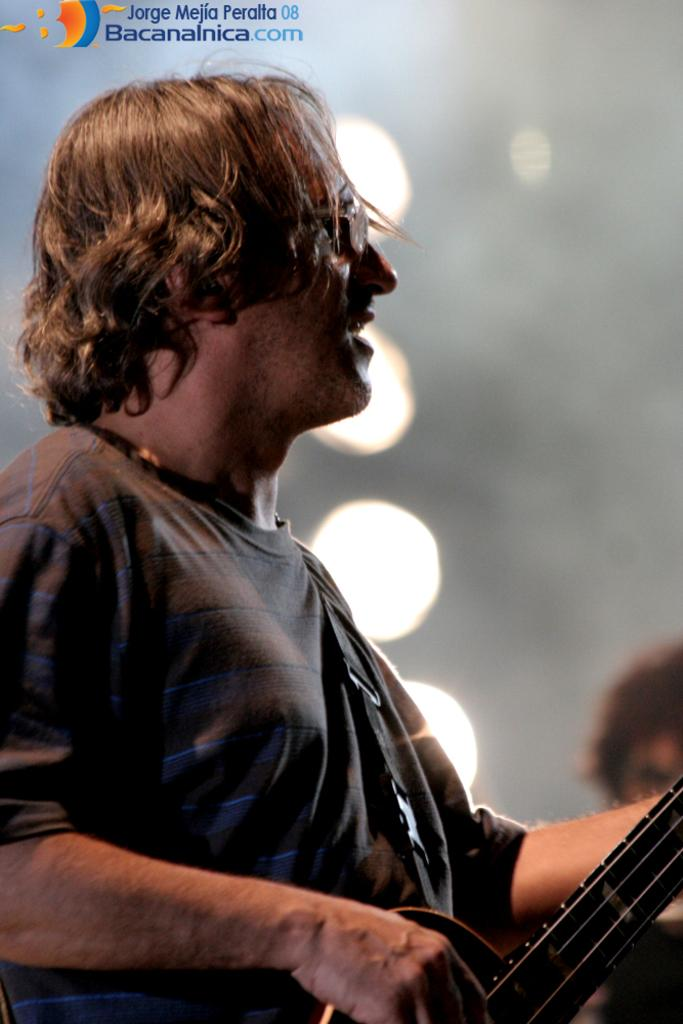What is the main subject of the image? The main subject of the image is a man. What is the man doing in the image? The man is standing and playing the guitar. What type of vessel is the man using to play the guitar in the image? There is no vessel present in the image; the man is playing the guitar with his hands. What acting role does the man have in the image? The image does not depict a specific acting role; it simply shows a man playing the guitar. 